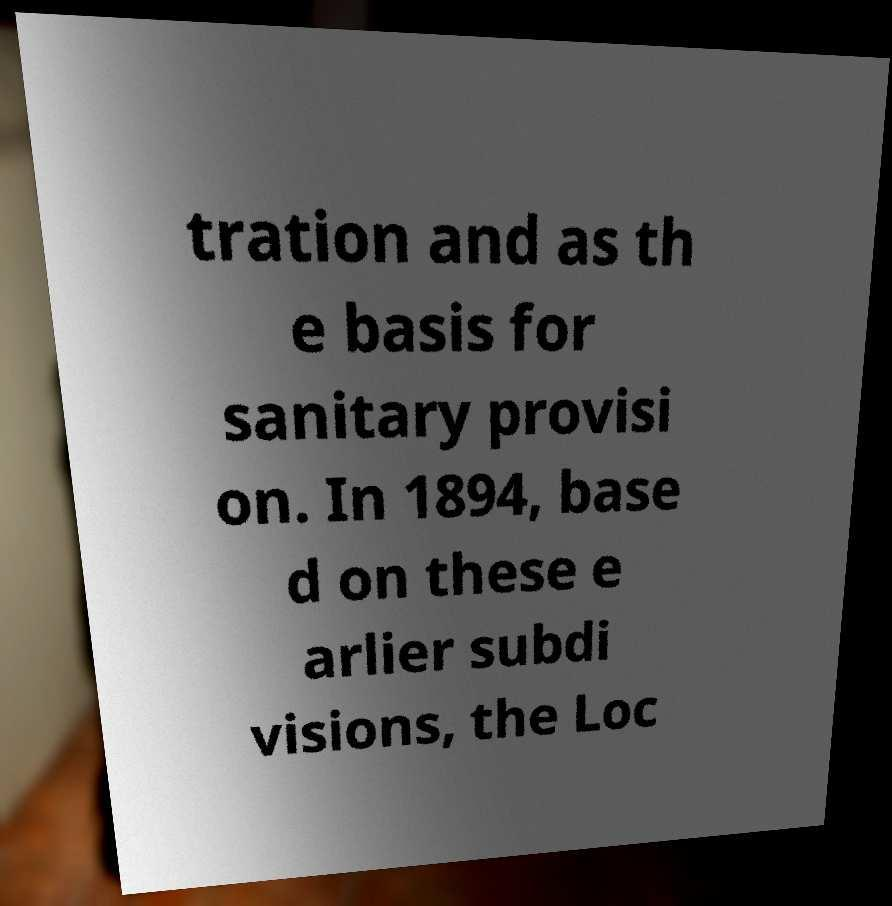I need the written content from this picture converted into text. Can you do that? tration and as th e basis for sanitary provisi on. In 1894, base d on these e arlier subdi visions, the Loc 